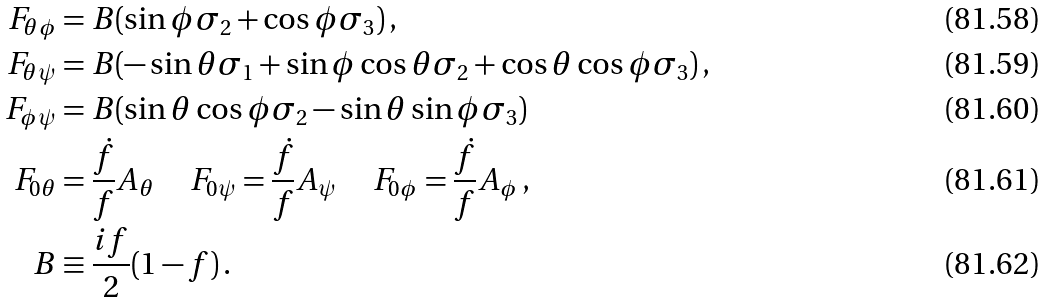<formula> <loc_0><loc_0><loc_500><loc_500>F _ { \theta \phi } & = B ( \sin \phi \sigma _ { 2 } + \cos \phi \sigma _ { 3 } ) \, , \\ F _ { \theta \psi } & = B ( - \sin \theta \sigma _ { 1 } + \sin \phi \cos \theta \sigma _ { 2 } + \cos \theta \cos \phi \sigma _ { 3 } ) \, , \\ F _ { \phi \psi } & = B ( \sin \theta \cos \phi \sigma _ { 2 } - \sin \theta \sin \phi \sigma _ { 3 } ) \, \\ F _ { 0 \theta } & = \frac { \dot { f } } { f } A _ { \theta } \, \quad F _ { 0 \psi } = \frac { \dot { f } } { f } A _ { \psi } \, \quad F _ { 0 \phi } = \frac { \dot { f } } { f } A _ { \phi } \, , \\ B & \equiv \frac { i f } { 2 } ( 1 - f ) \, .</formula> 